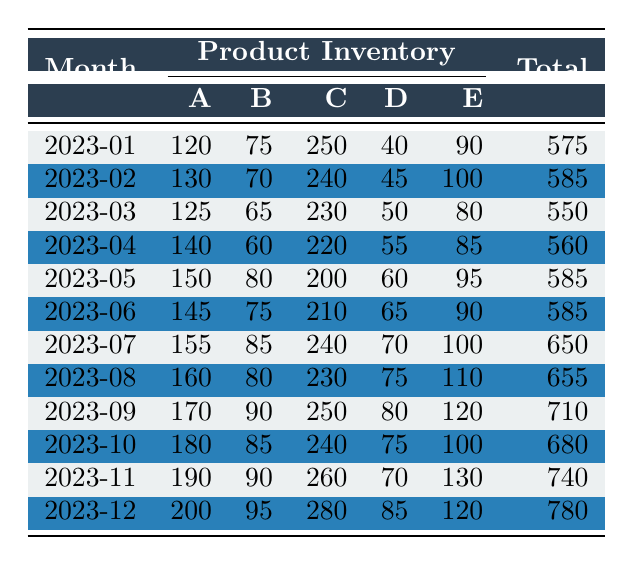What was the total inventory level in December 2023? In the row for December 2023, the Total Inventory value is listed. Looking at that row, the Total Inventory is 780.
Answer: 780 Which product had the highest inventory value in November 2023? In November 2023, comparing the inventory levels of all products, Product C has the highest value at 260.
Answer: Product C How much has the inventory of Product A increased from January to December 2023? The inventory of Product A in January 2023 was 120 and in December 2023 it is 200. The increase is calculated as 200 - 120 = 80.
Answer: 80 What is the average monthly total inventory level over the year? To find the average, sum all monthly total inventory values (575 + 585 + ... + 780 = 7,065) and divide by 12 (the number of months), giving an average of 590.5.
Answer: 590.5 Did the total inventory level decrease in any month compared to the previous month? Looking through the Total Inventory values month by month, the values only show increases or remain the same from month to month, so there are no decreases.
Answer: No What was the highest total inventory level recorded in any month? By scanning through the Total Inventory values across all months, December 2023 has the highest total at 780.
Answer: 780 What is the difference in inventory levels of Product B between the highest and lowest months? The highest for Product B was 95 in December 2023 and the lowest was 60 in April 2023. The difference is calculated as 95 - 60 = 35.
Answer: 35 Which month had the highest inventory for Product D? Checking the Monthly Inventory Levels for Product D, the highest value is 85 in December 2023.
Answer: December 2023 What was the combined inventory level of Products C and E in July 2023? In July 2023, Product C had an inventory level of 240 and Product E had 100. Adding these gives 240 + 100 = 340.
Answer: 340 Is the total inventory in August greater than the average total inventory for the year? The total inventory for August 2023 is 655, and the average total inventory is approximately 590.5. Since 655 is greater than 590.5, the answer is yes.
Answer: Yes 